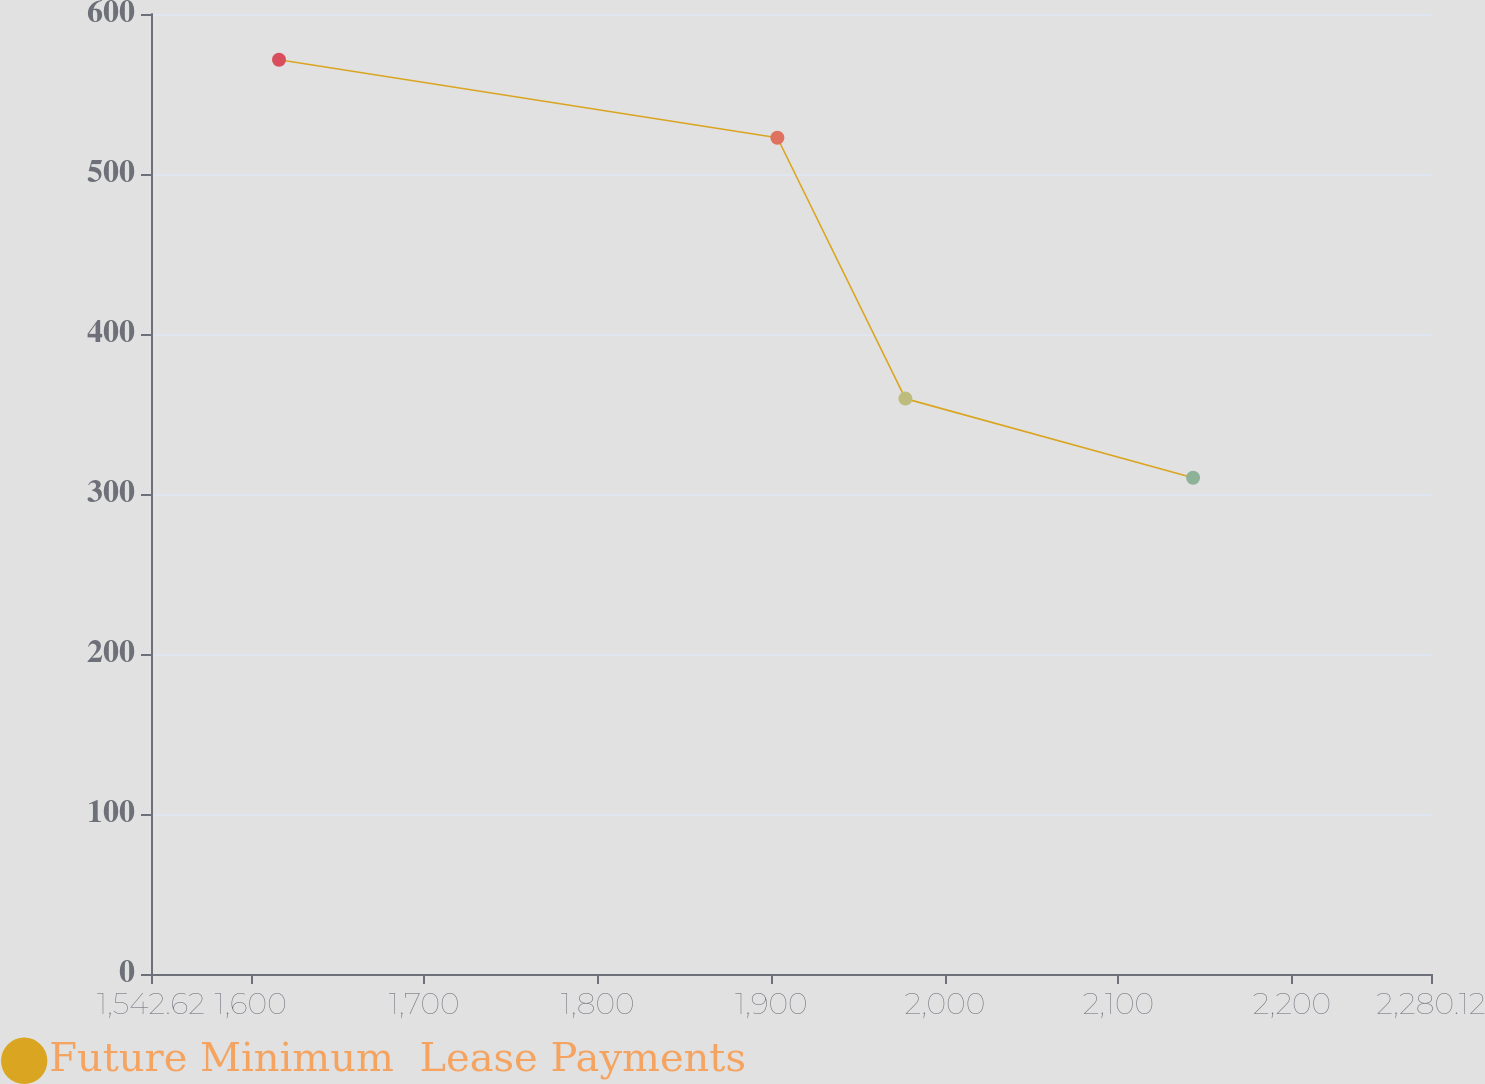<chart> <loc_0><loc_0><loc_500><loc_500><line_chart><ecel><fcel>Future Minimum  Lease Payments<nl><fcel>1616.37<fcel>571.37<nl><fcel>1903.52<fcel>522.66<nl><fcel>1977.27<fcel>359.62<nl><fcel>2143.04<fcel>310.13<nl><fcel>2353.87<fcel>243.66<nl></chart> 